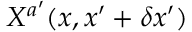<formula> <loc_0><loc_0><loc_500><loc_500>X ^ { a ^ { \prime } } ( x , x ^ { \prime } + \delta x ^ { \prime } )</formula> 